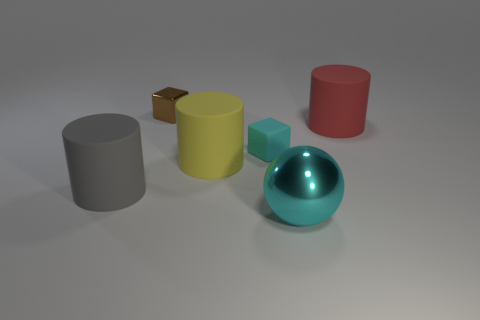There is a small thing that is the same color as the large ball; what shape is it?
Provide a succinct answer. Cube. Do the tiny matte cube and the big sphere have the same color?
Make the answer very short. Yes. There is a block that is the same color as the ball; what is its size?
Make the answer very short. Small. What number of small rubber blocks are the same color as the metallic sphere?
Ensure brevity in your answer.  1. Does the yellow matte object have the same shape as the small cyan object?
Offer a terse response. No. What number of metal things are either big yellow cylinders or purple balls?
Make the answer very short. 0. What is the material of the thing that is the same color as the matte block?
Your response must be concise. Metal. Do the cyan rubber cube and the brown object have the same size?
Give a very brief answer. Yes. What number of things are tiny cyan matte things or rubber things to the left of the rubber cube?
Your response must be concise. 3. There is a cyan thing that is the same size as the yellow matte cylinder; what is its material?
Your response must be concise. Metal. 